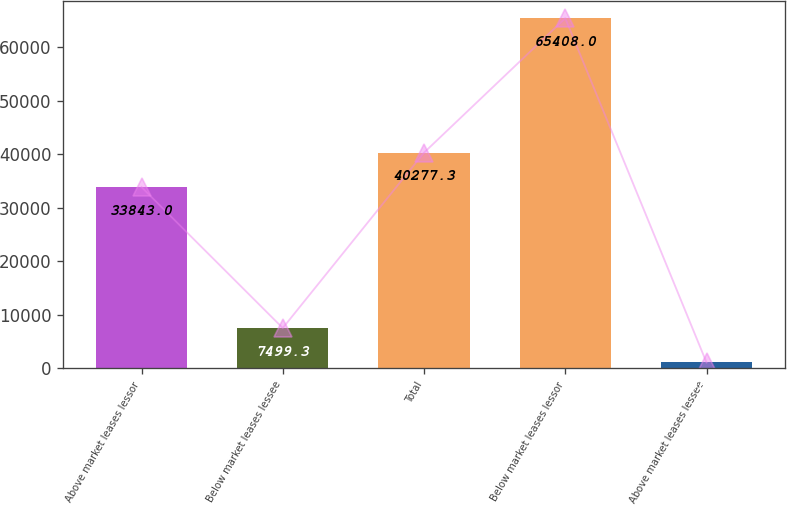Convert chart to OTSL. <chart><loc_0><loc_0><loc_500><loc_500><bar_chart><fcel>Above market leases lessor<fcel>Below market leases lessee<fcel>Total<fcel>Below market leases lessor<fcel>Above market leases lessee<nl><fcel>33843<fcel>7499.3<fcel>40277.3<fcel>65408<fcel>1065<nl></chart> 